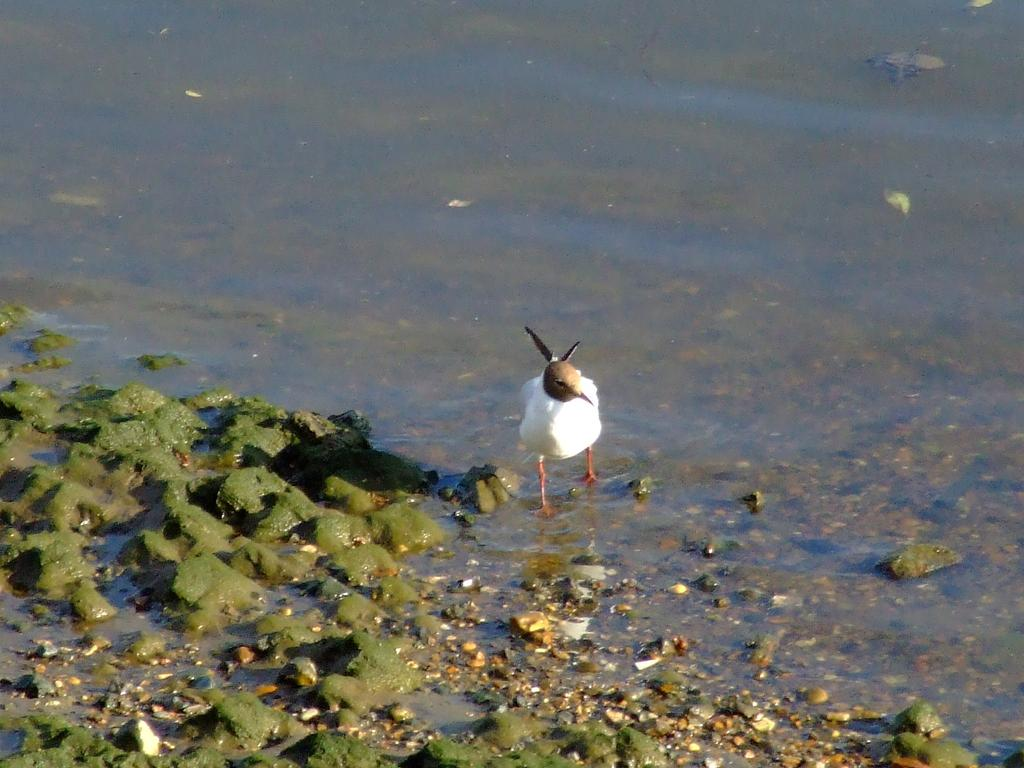What is the main subject in the center of the image? There is a bird in the center of the image. What type of environment is depicted in the image? There is water around the area of the image. What can be seen on the left side of the image? There is algae on the left side of the image. What type of desk can be seen in the image? There is no desk present in the image. Can you describe the plane visible in the image? There is no plane present in the image. 